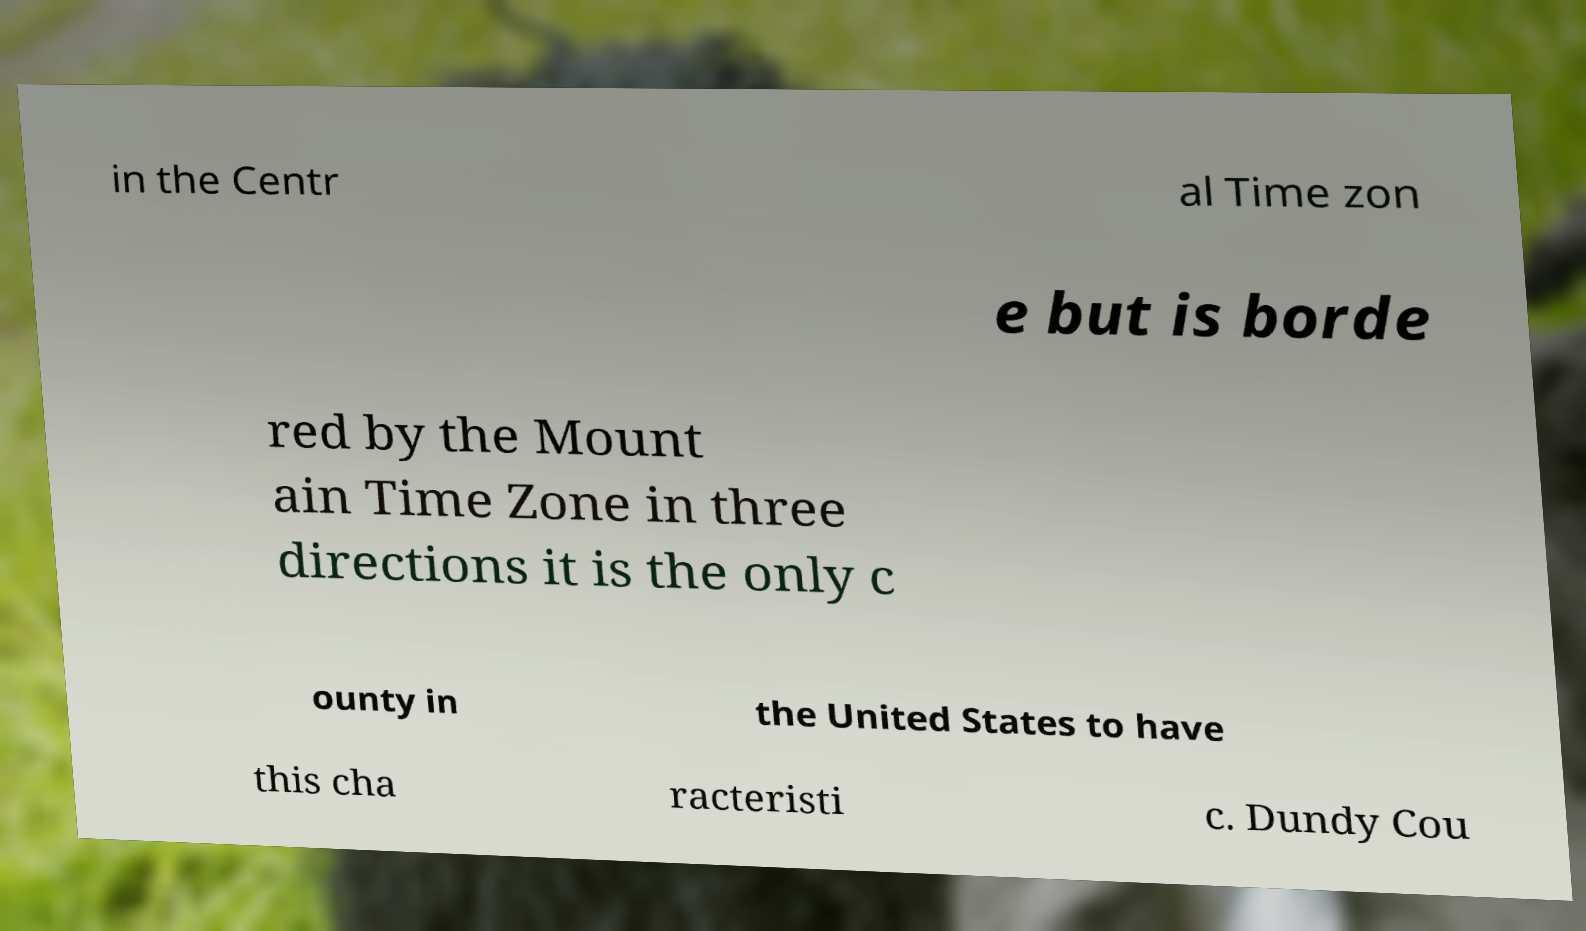Please identify and transcribe the text found in this image. in the Centr al Time zon e but is borde red by the Mount ain Time Zone in three directions it is the only c ounty in the United States to have this cha racteristi c. Dundy Cou 